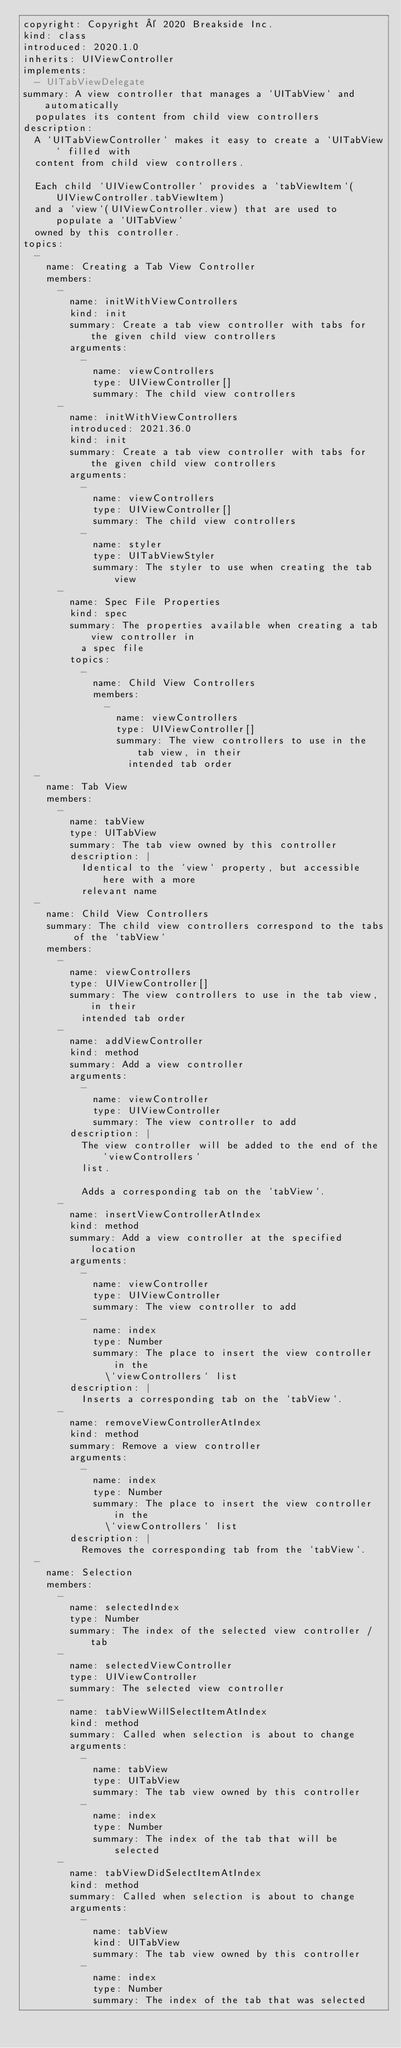<code> <loc_0><loc_0><loc_500><loc_500><_YAML_>copyright: Copyright © 2020 Breakside Inc.
kind: class
introduced: 2020.1.0
inherits: UIViewController
implements:
  - UITabViewDelegate
summary: A view controller that manages a `UITabView` and automatically
  populates its content from child view controllers
description:
  A `UITabViewController` makes it easy to create a `UITabView` filled with
  content from child view controllers.

  Each child `UIViewController` provides a `tabViewItem`(UIViewController.tabViewItem)
  and a `view`(UIViewController.view) that are used to populate a `UITabView`
  owned by this controller.
topics:
  -
    name: Creating a Tab View Controller
    members:
      -
        name: initWithViewControllers
        kind: init
        summary: Create a tab view controller with tabs for the given child view controllers
        arguments:
          -
            name: viewControllers
            type: UIViewController[]
            summary: The child view controllers
      -
        name: initWithViewControllers
        introduced: 2021.36.0
        kind: init
        summary: Create a tab view controller with tabs for the given child view controllers
        arguments:
          -
            name: viewControllers
            type: UIViewController[]
            summary: The child view controllers
          -
            name: styler
            type: UITabViewStyler
            summary: The styler to use when creating the tab view
      -
        name: Spec File Properties
        kind: spec
        summary: The properties available when creating a tab view controller in
          a spec file
        topics:
          -
            name: Child View Controllers
            members:
              -
                name: viewControllers
                type: UIViewController[]
                summary: The view controllers to use in the tab view, in their
                  intended tab order
  -
    name: Tab View
    members:
      -
        name: tabView
        type: UITabView
        summary: The tab view owned by this controller
        description: |
          Identical to the `view` property, but accessible here with a more
          relevant name
  -
    name: Child View Controllers
    summary: The child view controllers correspond to the tabs of the `tabView`
    members:
      -
        name: viewControllers
        type: UIViewController[]
        summary: The view controllers to use in the tab view, in their
          intended tab order
      -
        name: addViewController
        kind: method
        summary: Add a view controller
        arguments:
          -
            name: viewController
            type: UIViewController
            summary: The view controller to add
        description: |
          The view controller will be added to the end of the `viewControllers`
          list.

          Adds a corresponding tab on the `tabView`.
      -
        name: insertViewControllerAtIndex
        kind: method
        summary: Add a view controller at the specified location
        arguments:
          -
            name: viewController
            type: UIViewController
            summary: The view controller to add
          -
            name: index
            type: Number
            summary: The place to insert the view controller in the
              \`viewControllers` list
        description: |
          Inserts a corresponding tab on the `tabView`.
      -
        name: removeViewControllerAtIndex
        kind: method
        summary: Remove a view controller
        arguments:
          -
            name: index
            type: Number
            summary: The place to insert the view controller in the
              \`viewControllers` list
        description: |
          Removes the corresponding tab from the `tabView`.
  -
    name: Selection
    members:
      -
        name: selectedIndex
        type: Number
        summary: The index of the selected view controller / tab
      -
        name: selectedViewController
        type: UIViewController
        summary: The selected view controller
      -
        name: tabViewWillSelectItemAtIndex
        kind: method
        summary: Called when selection is about to change
        arguments:
          -
            name: tabView
            type: UITabView
            summary: The tab view owned by this controller
          -
            name: index
            type: Number
            summary: The index of the tab that will be selected
      -
        name: tabViewDidSelectItemAtIndex
        kind: method
        summary: Called when selection is about to change
        arguments:
          -
            name: tabView
            kind: UITabView
            summary: The tab view owned by this controller
          -
            name: index
            type: Number
            summary: The index of the tab that was selected</code> 